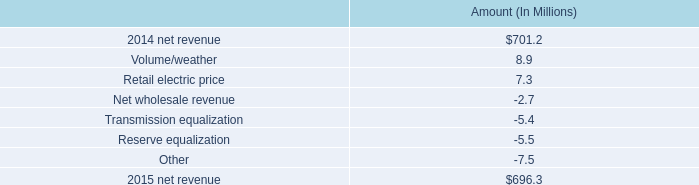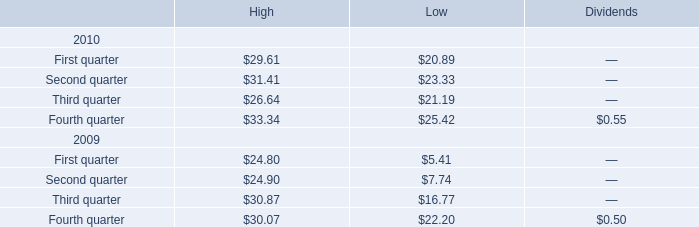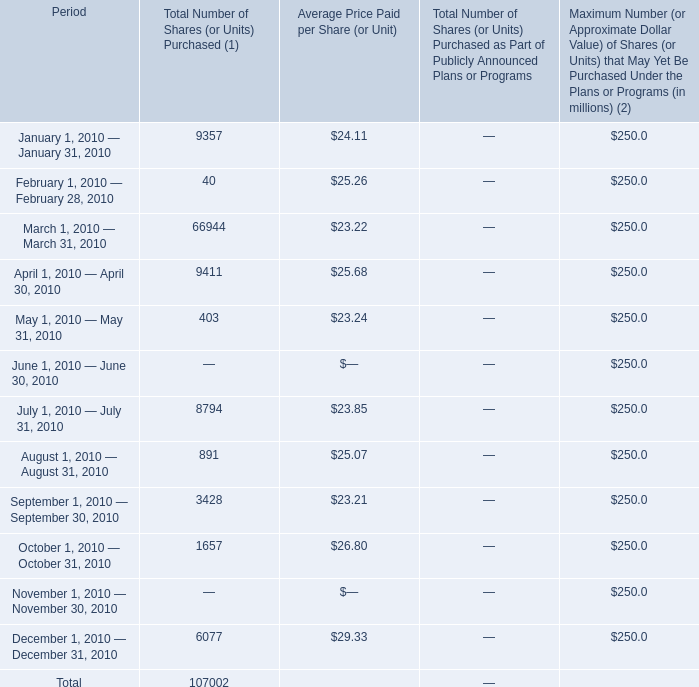In the month with the highest Average Price Paid per Share (or Unit) in 2010 , what's the Total Number of Shares (or Units) Purchased(1)? 
Answer: 6077. 